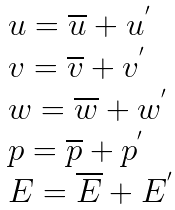Convert formula to latex. <formula><loc_0><loc_0><loc_500><loc_500>\begin{array} { l } u = \overline { u } + u ^ { ^ { \prime } } \\ v = \overline { v } + v ^ { ^ { \prime } } \\ w = \overline { w } + w ^ { ^ { \prime } } \\ p = \overline { p } + p ^ { ^ { \prime } } \\ E = \overline { E } + E ^ { ^ { \prime } } \end{array}</formula> 